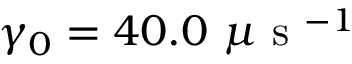Convert formula to latex. <formula><loc_0><loc_0><loc_500><loc_500>\gamma _ { 0 } = 4 0 . 0 \mu s ^ { - 1 }</formula> 